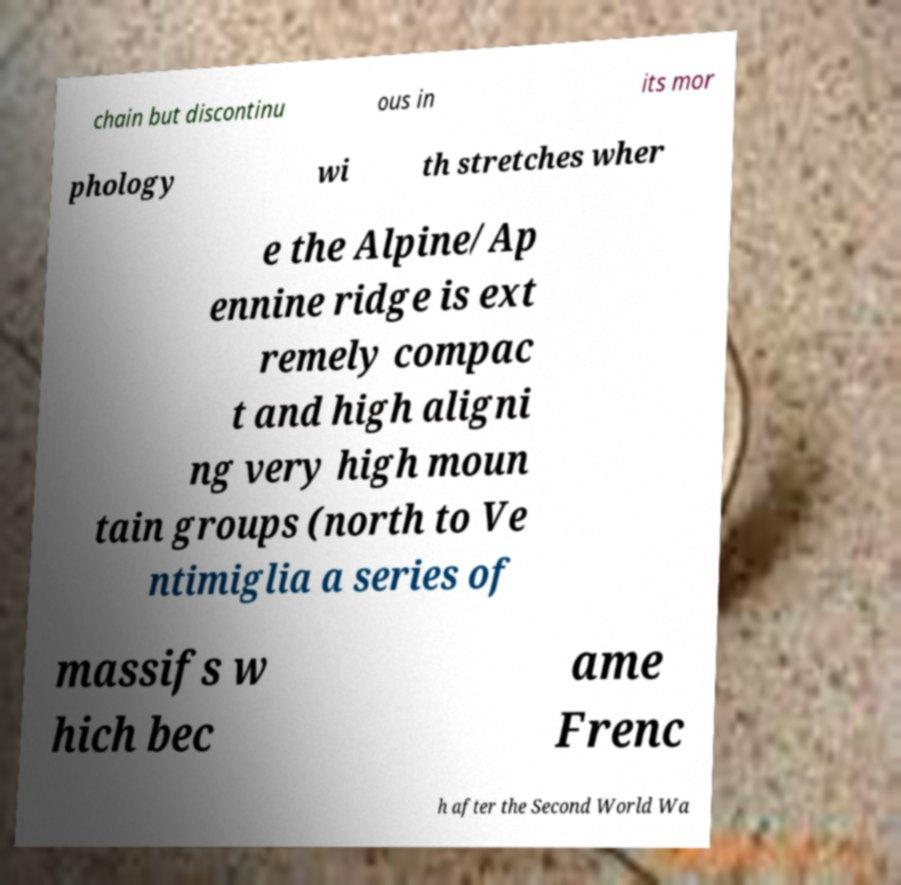There's text embedded in this image that I need extracted. Can you transcribe it verbatim? chain but discontinu ous in its mor phology wi th stretches wher e the Alpine/Ap ennine ridge is ext remely compac t and high aligni ng very high moun tain groups (north to Ve ntimiglia a series of massifs w hich bec ame Frenc h after the Second World Wa 